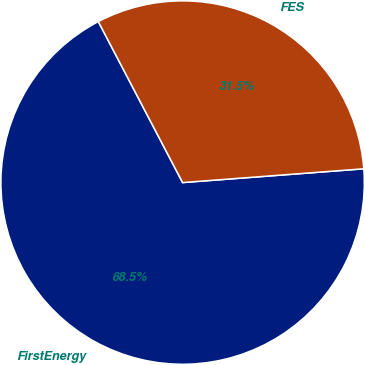Convert chart to OTSL. <chart><loc_0><loc_0><loc_500><loc_500><pie_chart><fcel>FirstEnergy<fcel>FES<nl><fcel>68.53%<fcel>31.47%<nl></chart> 